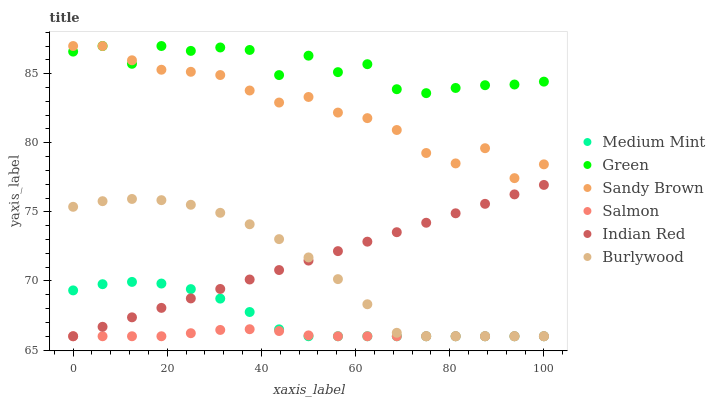Does Salmon have the minimum area under the curve?
Answer yes or no. Yes. Does Green have the maximum area under the curve?
Answer yes or no. Yes. Does Burlywood have the minimum area under the curve?
Answer yes or no. No. Does Burlywood have the maximum area under the curve?
Answer yes or no. No. Is Indian Red the smoothest?
Answer yes or no. Yes. Is Green the roughest?
Answer yes or no. Yes. Is Burlywood the smoothest?
Answer yes or no. No. Is Burlywood the roughest?
Answer yes or no. No. Does Medium Mint have the lowest value?
Answer yes or no. Yes. Does Green have the lowest value?
Answer yes or no. No. Does Sandy Brown have the highest value?
Answer yes or no. Yes. Does Burlywood have the highest value?
Answer yes or no. No. Is Salmon less than Green?
Answer yes or no. Yes. Is Green greater than Medium Mint?
Answer yes or no. Yes. Does Indian Red intersect Medium Mint?
Answer yes or no. Yes. Is Indian Red less than Medium Mint?
Answer yes or no. No. Is Indian Red greater than Medium Mint?
Answer yes or no. No. Does Salmon intersect Green?
Answer yes or no. No. 